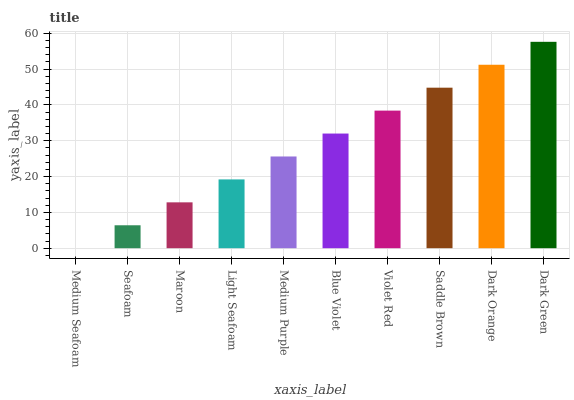Is Medium Seafoam the minimum?
Answer yes or no. Yes. Is Dark Green the maximum?
Answer yes or no. Yes. Is Seafoam the minimum?
Answer yes or no. No. Is Seafoam the maximum?
Answer yes or no. No. Is Seafoam greater than Medium Seafoam?
Answer yes or no. Yes. Is Medium Seafoam less than Seafoam?
Answer yes or no. Yes. Is Medium Seafoam greater than Seafoam?
Answer yes or no. No. Is Seafoam less than Medium Seafoam?
Answer yes or no. No. Is Blue Violet the high median?
Answer yes or no. Yes. Is Medium Purple the low median?
Answer yes or no. Yes. Is Seafoam the high median?
Answer yes or no. No. Is Seafoam the low median?
Answer yes or no. No. 